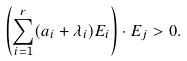<formula> <loc_0><loc_0><loc_500><loc_500>\left ( \sum _ { i = 1 } ^ { r } ( a _ { i } + \lambda _ { i } ) E _ { i } \right ) \cdot E _ { j } > 0 .</formula> 